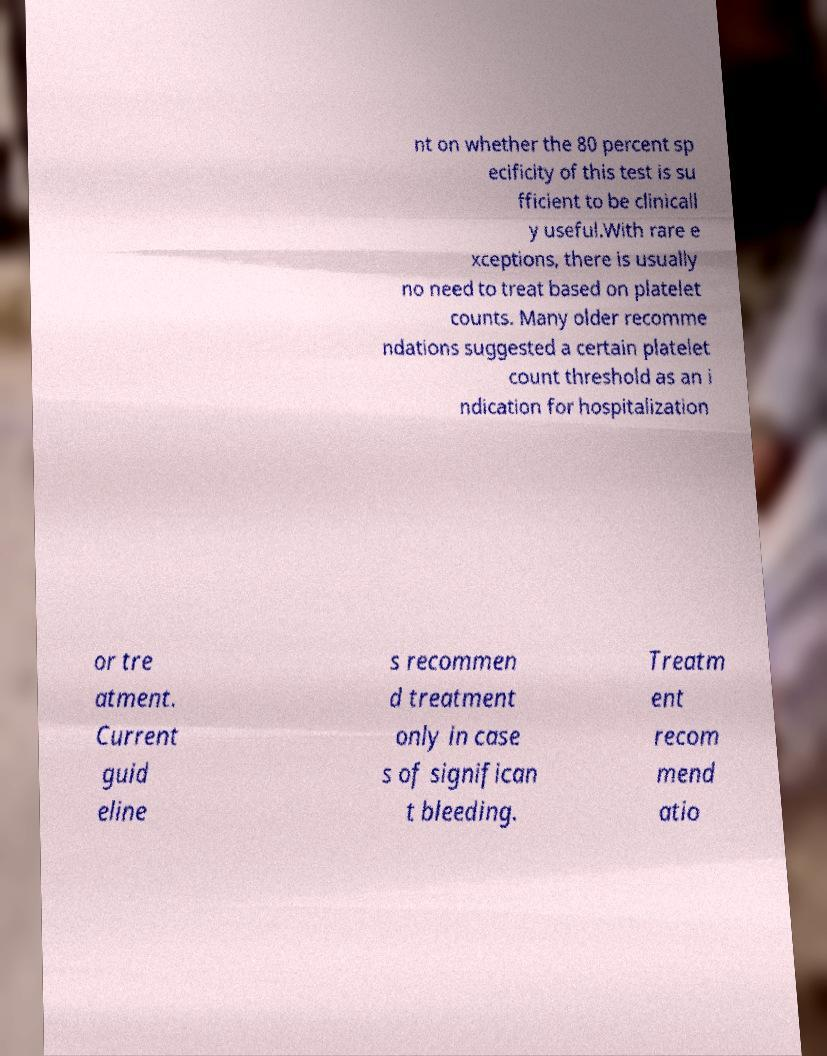Can you accurately transcribe the text from the provided image for me? nt on whether the 80 percent sp ecificity of this test is su fficient to be clinicall y useful.With rare e xceptions, there is usually no need to treat based on platelet counts. Many older recomme ndations suggested a certain platelet count threshold as an i ndication for hospitalization or tre atment. Current guid eline s recommen d treatment only in case s of significan t bleeding. Treatm ent recom mend atio 